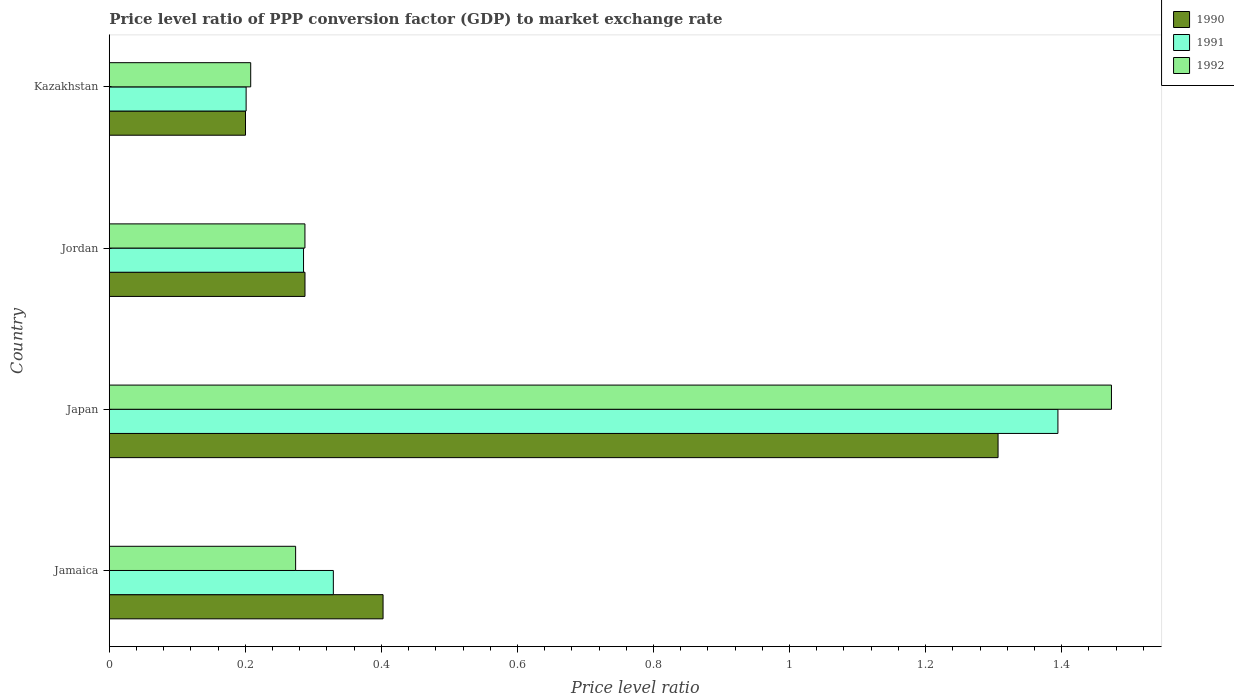How many groups of bars are there?
Your answer should be very brief. 4. Are the number of bars per tick equal to the number of legend labels?
Ensure brevity in your answer.  Yes. How many bars are there on the 4th tick from the top?
Provide a short and direct response. 3. What is the price level ratio in 1990 in Jamaica?
Your answer should be very brief. 0.4. Across all countries, what is the maximum price level ratio in 1990?
Your answer should be compact. 1.31. Across all countries, what is the minimum price level ratio in 1992?
Provide a short and direct response. 0.21. In which country was the price level ratio in 1992 minimum?
Your response must be concise. Kazakhstan. What is the total price level ratio in 1990 in the graph?
Give a very brief answer. 2.2. What is the difference between the price level ratio in 1992 in Jamaica and that in Jordan?
Your answer should be very brief. -0.01. What is the difference between the price level ratio in 1990 in Jordan and the price level ratio in 1991 in Jamaica?
Your answer should be very brief. -0.04. What is the average price level ratio in 1992 per country?
Provide a short and direct response. 0.56. What is the difference between the price level ratio in 1991 and price level ratio in 1992 in Japan?
Your answer should be compact. -0.08. What is the ratio of the price level ratio in 1991 in Japan to that in Jordan?
Make the answer very short. 4.88. Is the price level ratio in 1990 in Jamaica less than that in Kazakhstan?
Provide a short and direct response. No. What is the difference between the highest and the second highest price level ratio in 1992?
Provide a short and direct response. 1.19. What is the difference between the highest and the lowest price level ratio in 1991?
Your answer should be compact. 1.19. In how many countries, is the price level ratio in 1991 greater than the average price level ratio in 1991 taken over all countries?
Provide a succinct answer. 1. Is the sum of the price level ratio in 1992 in Jamaica and Japan greater than the maximum price level ratio in 1991 across all countries?
Make the answer very short. Yes. What does the 2nd bar from the bottom in Jordan represents?
Offer a very short reply. 1991. How many bars are there?
Offer a very short reply. 12. What is the difference between two consecutive major ticks on the X-axis?
Your answer should be very brief. 0.2. Are the values on the major ticks of X-axis written in scientific E-notation?
Ensure brevity in your answer.  No. Where does the legend appear in the graph?
Your response must be concise. Top right. How many legend labels are there?
Ensure brevity in your answer.  3. How are the legend labels stacked?
Offer a very short reply. Vertical. What is the title of the graph?
Your answer should be very brief. Price level ratio of PPP conversion factor (GDP) to market exchange rate. Does "1996" appear as one of the legend labels in the graph?
Offer a very short reply. No. What is the label or title of the X-axis?
Offer a terse response. Price level ratio. What is the label or title of the Y-axis?
Offer a very short reply. Country. What is the Price level ratio of 1990 in Jamaica?
Provide a short and direct response. 0.4. What is the Price level ratio in 1991 in Jamaica?
Provide a short and direct response. 0.33. What is the Price level ratio of 1992 in Jamaica?
Give a very brief answer. 0.27. What is the Price level ratio of 1990 in Japan?
Your response must be concise. 1.31. What is the Price level ratio in 1991 in Japan?
Keep it short and to the point. 1.39. What is the Price level ratio in 1992 in Japan?
Give a very brief answer. 1.47. What is the Price level ratio of 1990 in Jordan?
Your answer should be compact. 0.29. What is the Price level ratio of 1991 in Jordan?
Offer a very short reply. 0.29. What is the Price level ratio in 1992 in Jordan?
Make the answer very short. 0.29. What is the Price level ratio in 1990 in Kazakhstan?
Ensure brevity in your answer.  0.2. What is the Price level ratio of 1991 in Kazakhstan?
Keep it short and to the point. 0.2. What is the Price level ratio of 1992 in Kazakhstan?
Keep it short and to the point. 0.21. Across all countries, what is the maximum Price level ratio of 1990?
Make the answer very short. 1.31. Across all countries, what is the maximum Price level ratio in 1991?
Offer a terse response. 1.39. Across all countries, what is the maximum Price level ratio of 1992?
Keep it short and to the point. 1.47. Across all countries, what is the minimum Price level ratio of 1990?
Your answer should be very brief. 0.2. Across all countries, what is the minimum Price level ratio in 1991?
Offer a terse response. 0.2. Across all countries, what is the minimum Price level ratio in 1992?
Make the answer very short. 0.21. What is the total Price level ratio of 1990 in the graph?
Provide a short and direct response. 2.2. What is the total Price level ratio of 1991 in the graph?
Your response must be concise. 2.21. What is the total Price level ratio of 1992 in the graph?
Provide a short and direct response. 2.24. What is the difference between the Price level ratio in 1990 in Jamaica and that in Japan?
Your answer should be compact. -0.9. What is the difference between the Price level ratio of 1991 in Jamaica and that in Japan?
Provide a short and direct response. -1.07. What is the difference between the Price level ratio in 1992 in Jamaica and that in Japan?
Your answer should be compact. -1.2. What is the difference between the Price level ratio of 1990 in Jamaica and that in Jordan?
Your answer should be compact. 0.11. What is the difference between the Price level ratio in 1991 in Jamaica and that in Jordan?
Your answer should be compact. 0.04. What is the difference between the Price level ratio in 1992 in Jamaica and that in Jordan?
Provide a short and direct response. -0.01. What is the difference between the Price level ratio of 1990 in Jamaica and that in Kazakhstan?
Offer a very short reply. 0.2. What is the difference between the Price level ratio of 1991 in Jamaica and that in Kazakhstan?
Provide a short and direct response. 0.13. What is the difference between the Price level ratio of 1992 in Jamaica and that in Kazakhstan?
Ensure brevity in your answer.  0.07. What is the difference between the Price level ratio in 1990 in Japan and that in Jordan?
Your answer should be very brief. 1.02. What is the difference between the Price level ratio of 1991 in Japan and that in Jordan?
Your answer should be very brief. 1.11. What is the difference between the Price level ratio in 1992 in Japan and that in Jordan?
Your answer should be compact. 1.19. What is the difference between the Price level ratio of 1990 in Japan and that in Kazakhstan?
Your answer should be compact. 1.11. What is the difference between the Price level ratio in 1991 in Japan and that in Kazakhstan?
Make the answer very short. 1.19. What is the difference between the Price level ratio in 1992 in Japan and that in Kazakhstan?
Your answer should be very brief. 1.27. What is the difference between the Price level ratio in 1990 in Jordan and that in Kazakhstan?
Your response must be concise. 0.09. What is the difference between the Price level ratio in 1991 in Jordan and that in Kazakhstan?
Your answer should be very brief. 0.08. What is the difference between the Price level ratio of 1992 in Jordan and that in Kazakhstan?
Your response must be concise. 0.08. What is the difference between the Price level ratio in 1990 in Jamaica and the Price level ratio in 1991 in Japan?
Your answer should be compact. -0.99. What is the difference between the Price level ratio in 1990 in Jamaica and the Price level ratio in 1992 in Japan?
Your answer should be compact. -1.07. What is the difference between the Price level ratio of 1991 in Jamaica and the Price level ratio of 1992 in Japan?
Ensure brevity in your answer.  -1.14. What is the difference between the Price level ratio of 1990 in Jamaica and the Price level ratio of 1991 in Jordan?
Keep it short and to the point. 0.12. What is the difference between the Price level ratio of 1990 in Jamaica and the Price level ratio of 1992 in Jordan?
Provide a short and direct response. 0.11. What is the difference between the Price level ratio in 1991 in Jamaica and the Price level ratio in 1992 in Jordan?
Provide a short and direct response. 0.04. What is the difference between the Price level ratio of 1990 in Jamaica and the Price level ratio of 1991 in Kazakhstan?
Your answer should be very brief. 0.2. What is the difference between the Price level ratio in 1990 in Jamaica and the Price level ratio in 1992 in Kazakhstan?
Offer a terse response. 0.19. What is the difference between the Price level ratio of 1991 in Jamaica and the Price level ratio of 1992 in Kazakhstan?
Your answer should be very brief. 0.12. What is the difference between the Price level ratio of 1990 in Japan and the Price level ratio of 1991 in Jordan?
Provide a succinct answer. 1.02. What is the difference between the Price level ratio in 1990 in Japan and the Price level ratio in 1992 in Jordan?
Offer a very short reply. 1.02. What is the difference between the Price level ratio in 1991 in Japan and the Price level ratio in 1992 in Jordan?
Offer a terse response. 1.11. What is the difference between the Price level ratio in 1990 in Japan and the Price level ratio in 1991 in Kazakhstan?
Offer a terse response. 1.11. What is the difference between the Price level ratio of 1990 in Japan and the Price level ratio of 1992 in Kazakhstan?
Make the answer very short. 1.1. What is the difference between the Price level ratio of 1991 in Japan and the Price level ratio of 1992 in Kazakhstan?
Provide a short and direct response. 1.19. What is the difference between the Price level ratio in 1990 in Jordan and the Price level ratio in 1991 in Kazakhstan?
Ensure brevity in your answer.  0.09. What is the difference between the Price level ratio in 1990 in Jordan and the Price level ratio in 1992 in Kazakhstan?
Make the answer very short. 0.08. What is the difference between the Price level ratio in 1991 in Jordan and the Price level ratio in 1992 in Kazakhstan?
Make the answer very short. 0.08. What is the average Price level ratio of 1990 per country?
Provide a succinct answer. 0.55. What is the average Price level ratio of 1991 per country?
Provide a succinct answer. 0.55. What is the average Price level ratio in 1992 per country?
Your response must be concise. 0.56. What is the difference between the Price level ratio in 1990 and Price level ratio in 1991 in Jamaica?
Your answer should be very brief. 0.07. What is the difference between the Price level ratio in 1990 and Price level ratio in 1992 in Jamaica?
Provide a succinct answer. 0.13. What is the difference between the Price level ratio of 1991 and Price level ratio of 1992 in Jamaica?
Make the answer very short. 0.06. What is the difference between the Price level ratio of 1990 and Price level ratio of 1991 in Japan?
Offer a terse response. -0.09. What is the difference between the Price level ratio of 1991 and Price level ratio of 1992 in Japan?
Offer a very short reply. -0.08. What is the difference between the Price level ratio of 1990 and Price level ratio of 1991 in Jordan?
Offer a terse response. 0. What is the difference between the Price level ratio of 1991 and Price level ratio of 1992 in Jordan?
Make the answer very short. -0. What is the difference between the Price level ratio in 1990 and Price level ratio in 1991 in Kazakhstan?
Make the answer very short. -0. What is the difference between the Price level ratio of 1990 and Price level ratio of 1992 in Kazakhstan?
Offer a terse response. -0.01. What is the difference between the Price level ratio in 1991 and Price level ratio in 1992 in Kazakhstan?
Offer a terse response. -0.01. What is the ratio of the Price level ratio of 1990 in Jamaica to that in Japan?
Your answer should be very brief. 0.31. What is the ratio of the Price level ratio of 1991 in Jamaica to that in Japan?
Offer a very short reply. 0.24. What is the ratio of the Price level ratio in 1992 in Jamaica to that in Japan?
Ensure brevity in your answer.  0.19. What is the ratio of the Price level ratio of 1990 in Jamaica to that in Jordan?
Keep it short and to the point. 1.4. What is the ratio of the Price level ratio of 1991 in Jamaica to that in Jordan?
Your answer should be very brief. 1.15. What is the ratio of the Price level ratio of 1992 in Jamaica to that in Jordan?
Your answer should be very brief. 0.95. What is the ratio of the Price level ratio in 1990 in Jamaica to that in Kazakhstan?
Make the answer very short. 2.01. What is the ratio of the Price level ratio in 1991 in Jamaica to that in Kazakhstan?
Your response must be concise. 1.64. What is the ratio of the Price level ratio of 1992 in Jamaica to that in Kazakhstan?
Ensure brevity in your answer.  1.32. What is the ratio of the Price level ratio in 1990 in Japan to that in Jordan?
Ensure brevity in your answer.  4.54. What is the ratio of the Price level ratio in 1991 in Japan to that in Jordan?
Make the answer very short. 4.88. What is the ratio of the Price level ratio of 1992 in Japan to that in Jordan?
Give a very brief answer. 5.12. What is the ratio of the Price level ratio in 1990 in Japan to that in Kazakhstan?
Your answer should be compact. 6.52. What is the ratio of the Price level ratio of 1991 in Japan to that in Kazakhstan?
Keep it short and to the point. 6.93. What is the ratio of the Price level ratio in 1992 in Japan to that in Kazakhstan?
Your answer should be very brief. 7.09. What is the ratio of the Price level ratio in 1990 in Jordan to that in Kazakhstan?
Offer a very short reply. 1.44. What is the ratio of the Price level ratio of 1991 in Jordan to that in Kazakhstan?
Keep it short and to the point. 1.42. What is the ratio of the Price level ratio in 1992 in Jordan to that in Kazakhstan?
Your answer should be very brief. 1.38. What is the difference between the highest and the second highest Price level ratio in 1990?
Give a very brief answer. 0.9. What is the difference between the highest and the second highest Price level ratio in 1991?
Offer a terse response. 1.07. What is the difference between the highest and the second highest Price level ratio of 1992?
Provide a short and direct response. 1.19. What is the difference between the highest and the lowest Price level ratio in 1990?
Keep it short and to the point. 1.11. What is the difference between the highest and the lowest Price level ratio of 1991?
Ensure brevity in your answer.  1.19. What is the difference between the highest and the lowest Price level ratio in 1992?
Give a very brief answer. 1.27. 